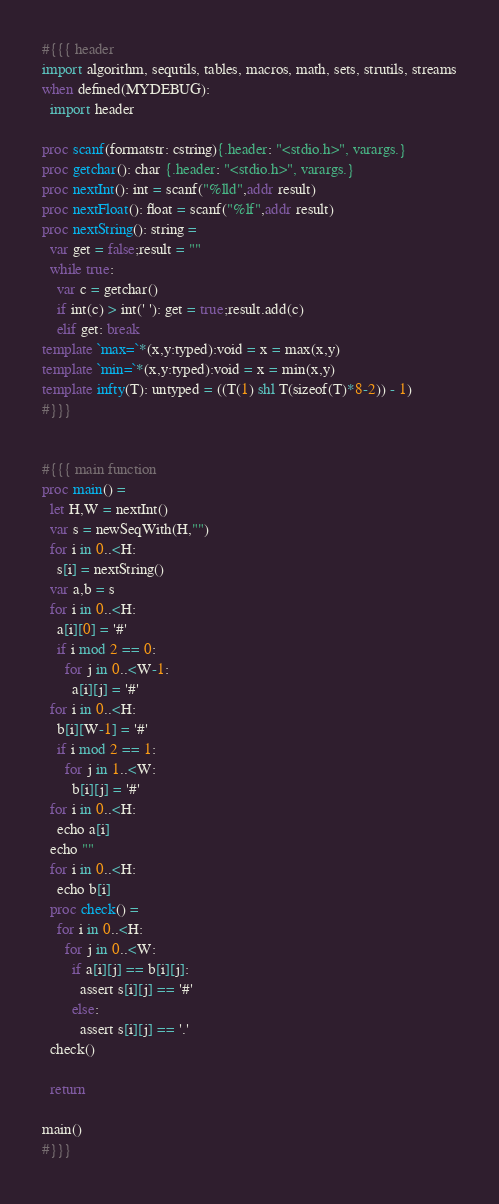Convert code to text. <code><loc_0><loc_0><loc_500><loc_500><_Nim_>#{{{ header
import algorithm, sequtils, tables, macros, math, sets, strutils, streams
when defined(MYDEBUG):
  import header

proc scanf(formatstr: cstring){.header: "<stdio.h>", varargs.}
proc getchar(): char {.header: "<stdio.h>", varargs.}
proc nextInt(): int = scanf("%lld",addr result)
proc nextFloat(): float = scanf("%lf",addr result)
proc nextString(): string =
  var get = false;result = ""
  while true:
    var c = getchar()
    if int(c) > int(' '): get = true;result.add(c)
    elif get: break
template `max=`*(x,y:typed):void = x = max(x,y)
template `min=`*(x,y:typed):void = x = min(x,y)
template infty(T): untyped = ((T(1) shl T(sizeof(T)*8-2)) - 1)
#}}}


#{{{ main function
proc main() =
  let H,W = nextInt()
  var s = newSeqWith(H,"")
  for i in 0..<H:
    s[i] = nextString()
  var a,b = s
  for i in 0..<H:
    a[i][0] = '#'
    if i mod 2 == 0:
      for j in 0..<W-1:
        a[i][j] = '#'
  for i in 0..<H:
    b[i][W-1] = '#'
    if i mod 2 == 1:
      for j in 1..<W:
        b[i][j] = '#'
  for i in 0..<H:
    echo a[i]
  echo ""
  for i in 0..<H:
    echo b[i]
  proc check() =
    for i in 0..<H:
      for j in 0..<W:
        if a[i][j] == b[i][j]:
          assert s[i][j] == '#'
        else:
          assert s[i][j] == '.'
  check()

  return

main()
#}}}</code> 